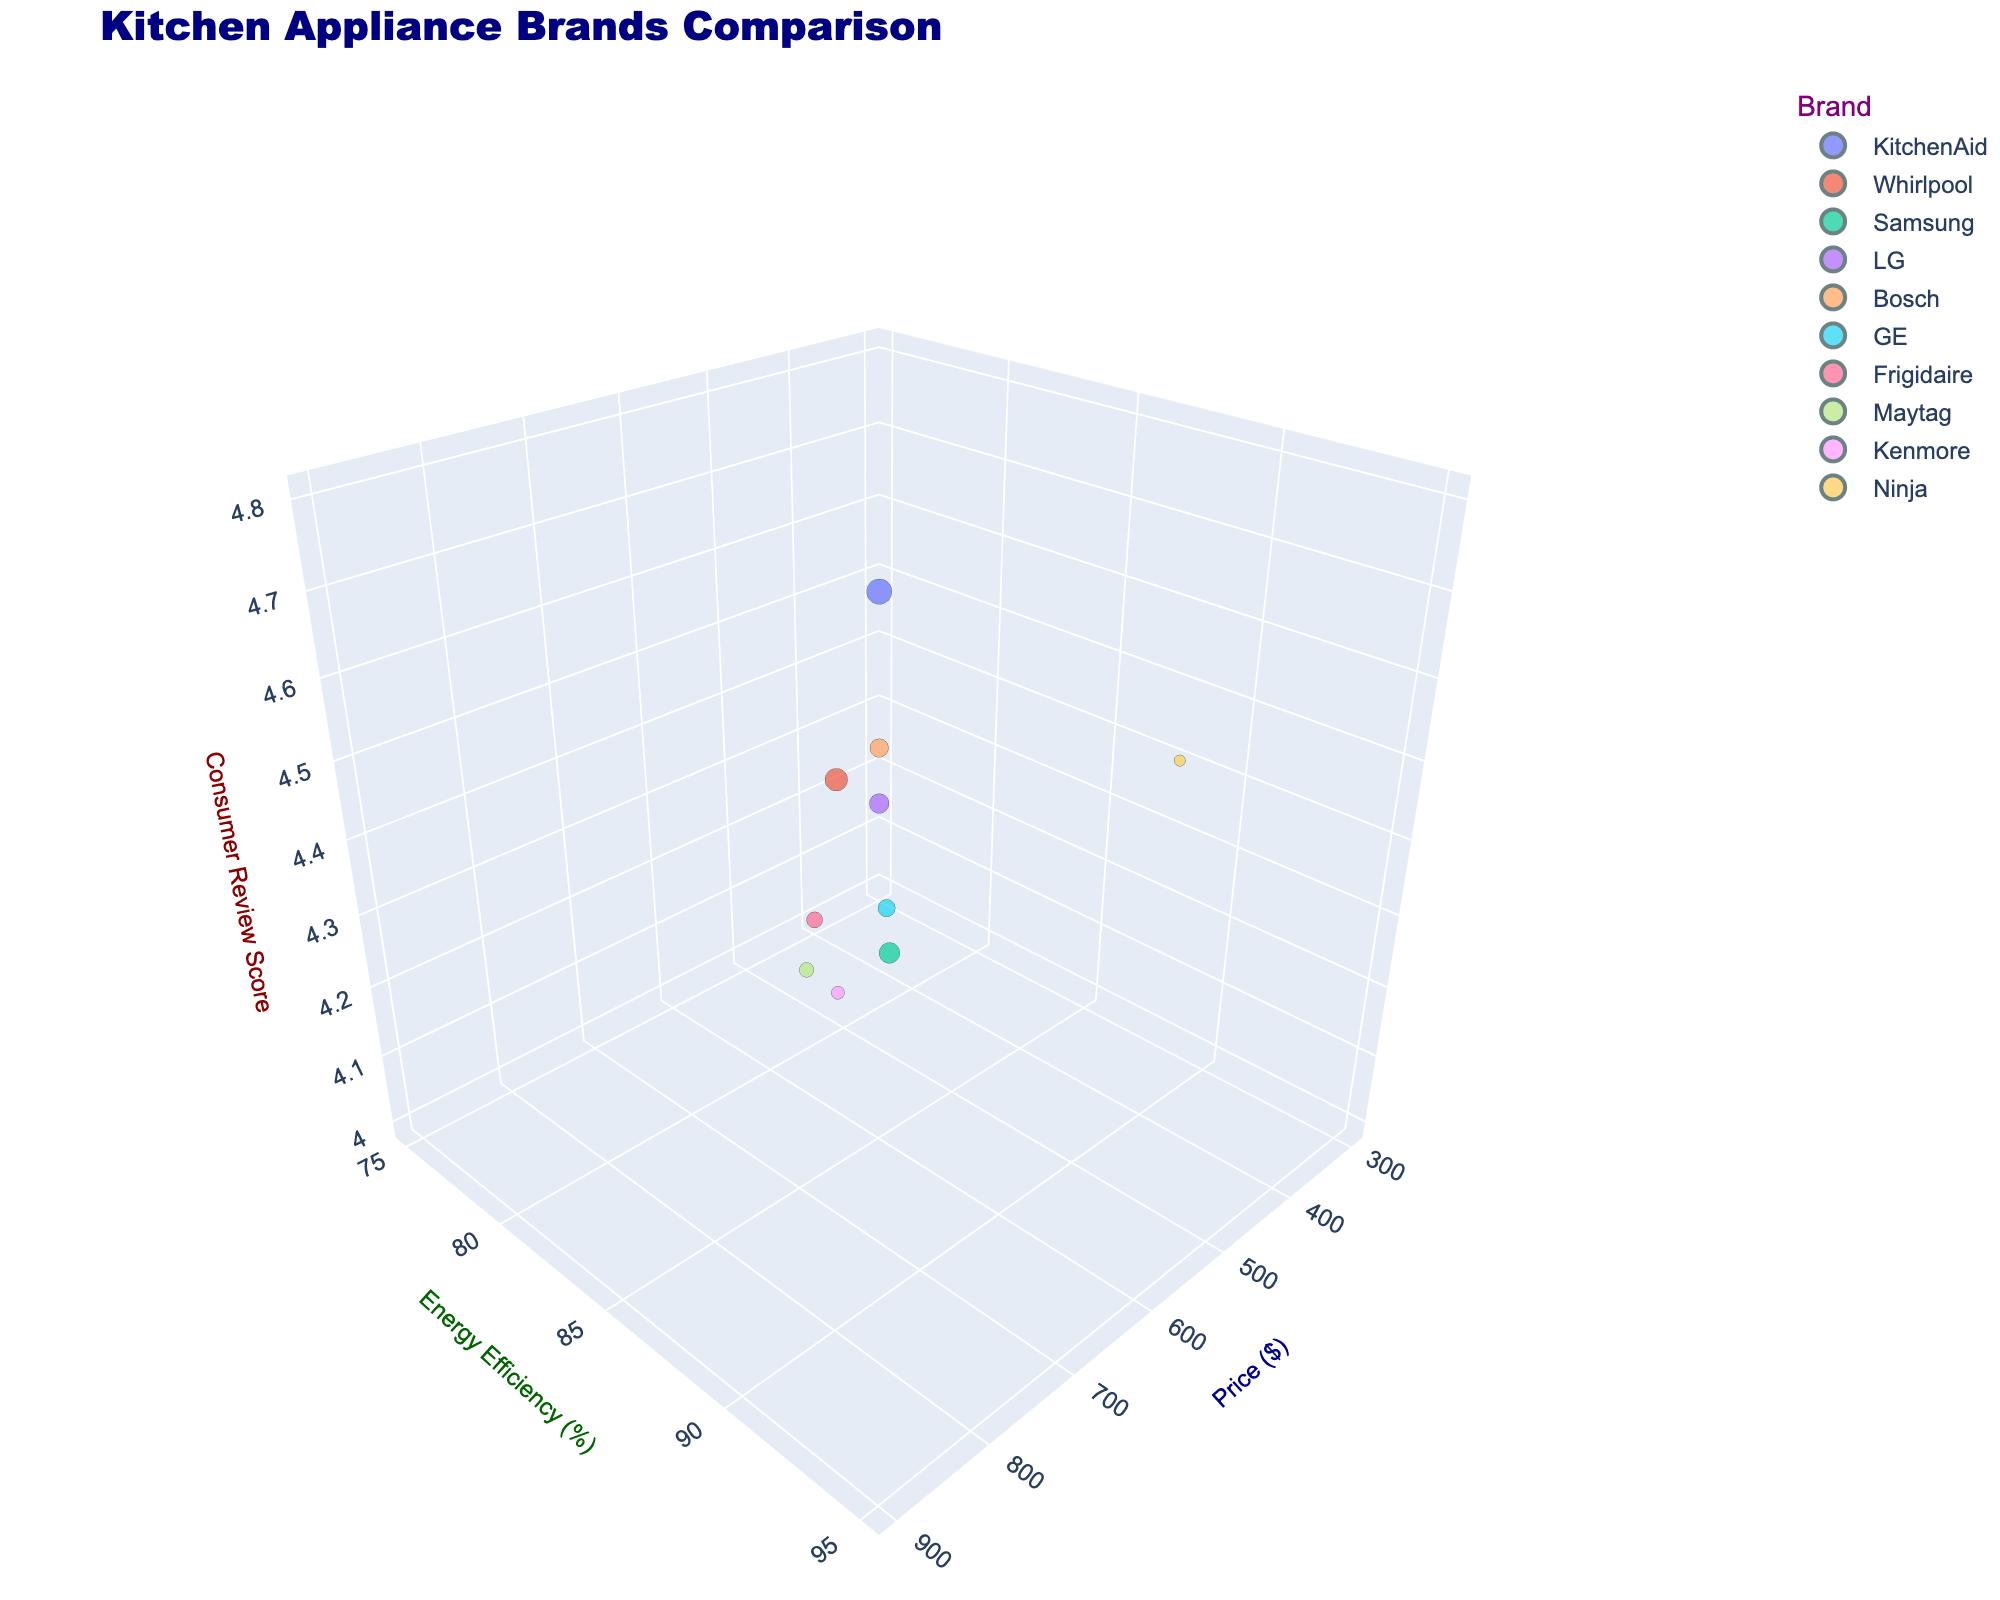What's the title of the figure? The title is typically displayed at the top of the chart and provides an overview of what the chart represents. In this chart, the title is clearly visible at the top.
Answer: Kitchen Appliance Brands Comparison Which brand has the highest Consumer Review Score? Identify the data point with the highest position on the z-axis as it represents the Consumer Review Score. Bosch has the highest score of 4.8.
Answer: Bosch Which brand has the lowest price? Look at the x-axis which represents the price and identify the leftmost data point. Ninja has the lowest price of $299.
Answer: Ninja Which brand has the largest market share? The size of the bubbles represents market share, so identify the largest bubble. KitchenAid has the largest market share at 15%.
Answer: KitchenAid Compare the Energy Efficiency of Samsung and LG. Which is higher? Identify the positions of Samsung and LG on the y-axis. Samsung has an energy efficiency of 92%, while LG has 90%. So, Samsung's energy efficiency is higher.
Answer: Samsung Which brand has the best combination of price and Consumer Review Score? Look for the bubble that is close to the bottom of the pricing scale (x-axis) and high on the Consumer Review Score (z-axis). Ninja has a relatively low price of $299 and a good review score of 4.4.
Answer: Ninja What is the average price of all the brands? Sum the prices of all brands and divide by the number of brands. (599 + 449 + 799 + 749 + 899 + 499 + 399 + 549 + 479 + 299) / 10 = 5720 / 10 = 572.
Answer: 572 Which brand has the most balanced attributes in terms of Price, Energy Efficiency, and Consumer Review Score? Look for a brand that has moderate values across all three axes. GE has a price of $499, energy efficiency of 82%, and a consumer review score of 4.2, making it balanced.
Answer: GE What is the difference between the highest and lowest Consumer Review Scores? Identify the highest and lowest values on the z-axis. Bosch has the highest score (4.8) and Frigidaire and Kenmore have the lowest (4.0). The difference is 4.8 - 4.0 = 0.8.
Answer: 0.8 Which brand would be considered the most energy-efficient? Identify the data point that is highest on the y-axis. Bosch has the highest energy efficiency at 95%.
Answer: Bosch 